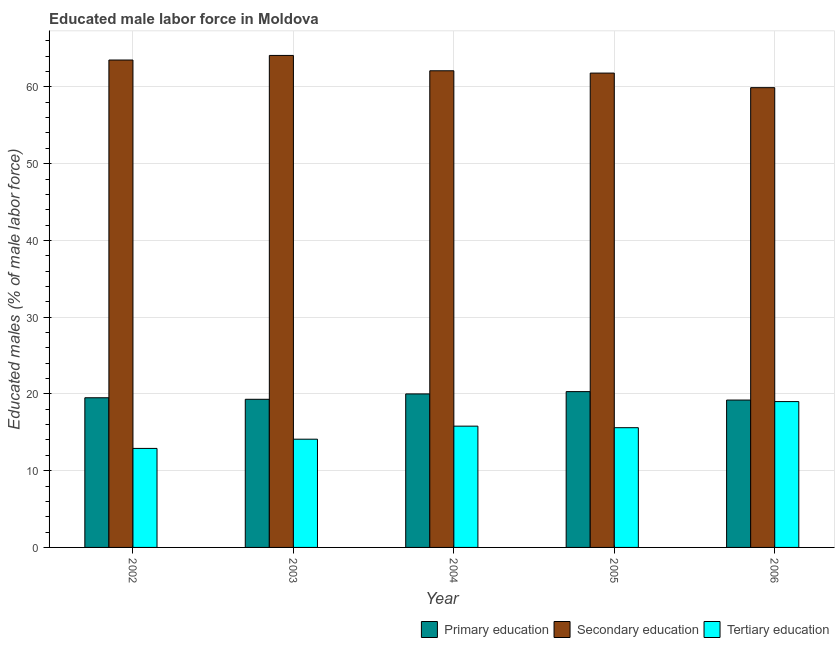How many different coloured bars are there?
Keep it short and to the point. 3. What is the percentage of male labor force who received secondary education in 2004?
Keep it short and to the point. 62.1. Across all years, what is the minimum percentage of male labor force who received tertiary education?
Ensure brevity in your answer.  12.9. In which year was the percentage of male labor force who received primary education maximum?
Your response must be concise. 2005. In which year was the percentage of male labor force who received secondary education minimum?
Make the answer very short. 2006. What is the total percentage of male labor force who received primary education in the graph?
Provide a succinct answer. 98.3. What is the difference between the percentage of male labor force who received secondary education in 2002 and that in 2006?
Your response must be concise. 3.6. What is the difference between the percentage of male labor force who received primary education in 2006 and the percentage of male labor force who received tertiary education in 2005?
Provide a short and direct response. -1.1. What is the average percentage of male labor force who received primary education per year?
Offer a terse response. 19.66. In how many years, is the percentage of male labor force who received tertiary education greater than 32 %?
Provide a succinct answer. 0. What is the ratio of the percentage of male labor force who received tertiary education in 2002 to that in 2005?
Ensure brevity in your answer.  0.83. Is the difference between the percentage of male labor force who received secondary education in 2002 and 2005 greater than the difference between the percentage of male labor force who received primary education in 2002 and 2005?
Your response must be concise. No. What is the difference between the highest and the second highest percentage of male labor force who received secondary education?
Keep it short and to the point. 0.6. What is the difference between the highest and the lowest percentage of male labor force who received primary education?
Your answer should be compact. 1.1. In how many years, is the percentage of male labor force who received tertiary education greater than the average percentage of male labor force who received tertiary education taken over all years?
Offer a terse response. 3. Is the sum of the percentage of male labor force who received primary education in 2004 and 2006 greater than the maximum percentage of male labor force who received tertiary education across all years?
Give a very brief answer. Yes. What does the 1st bar from the right in 2003 represents?
Your answer should be compact. Tertiary education. How many bars are there?
Offer a terse response. 15. Are the values on the major ticks of Y-axis written in scientific E-notation?
Offer a terse response. No. Does the graph contain any zero values?
Your response must be concise. No. Does the graph contain grids?
Your response must be concise. Yes. What is the title of the graph?
Your response must be concise. Educated male labor force in Moldova. What is the label or title of the X-axis?
Provide a short and direct response. Year. What is the label or title of the Y-axis?
Offer a very short reply. Educated males (% of male labor force). What is the Educated males (% of male labor force) of Primary education in 2002?
Give a very brief answer. 19.5. What is the Educated males (% of male labor force) in Secondary education in 2002?
Keep it short and to the point. 63.5. What is the Educated males (% of male labor force) of Tertiary education in 2002?
Ensure brevity in your answer.  12.9. What is the Educated males (% of male labor force) in Primary education in 2003?
Offer a terse response. 19.3. What is the Educated males (% of male labor force) in Secondary education in 2003?
Give a very brief answer. 64.1. What is the Educated males (% of male labor force) of Tertiary education in 2003?
Ensure brevity in your answer.  14.1. What is the Educated males (% of male labor force) of Secondary education in 2004?
Make the answer very short. 62.1. What is the Educated males (% of male labor force) of Tertiary education in 2004?
Provide a short and direct response. 15.8. What is the Educated males (% of male labor force) in Primary education in 2005?
Offer a very short reply. 20.3. What is the Educated males (% of male labor force) in Secondary education in 2005?
Offer a very short reply. 61.8. What is the Educated males (% of male labor force) in Tertiary education in 2005?
Provide a short and direct response. 15.6. What is the Educated males (% of male labor force) in Primary education in 2006?
Make the answer very short. 19.2. What is the Educated males (% of male labor force) of Secondary education in 2006?
Make the answer very short. 59.9. Across all years, what is the maximum Educated males (% of male labor force) of Primary education?
Your response must be concise. 20.3. Across all years, what is the maximum Educated males (% of male labor force) of Secondary education?
Ensure brevity in your answer.  64.1. Across all years, what is the maximum Educated males (% of male labor force) of Tertiary education?
Your response must be concise. 19. Across all years, what is the minimum Educated males (% of male labor force) of Primary education?
Give a very brief answer. 19.2. Across all years, what is the minimum Educated males (% of male labor force) in Secondary education?
Ensure brevity in your answer.  59.9. Across all years, what is the minimum Educated males (% of male labor force) of Tertiary education?
Your answer should be compact. 12.9. What is the total Educated males (% of male labor force) of Primary education in the graph?
Ensure brevity in your answer.  98.3. What is the total Educated males (% of male labor force) of Secondary education in the graph?
Ensure brevity in your answer.  311.4. What is the total Educated males (% of male labor force) in Tertiary education in the graph?
Provide a succinct answer. 77.4. What is the difference between the Educated males (% of male labor force) of Primary education in 2002 and that in 2003?
Offer a terse response. 0.2. What is the difference between the Educated males (% of male labor force) in Secondary education in 2002 and that in 2003?
Give a very brief answer. -0.6. What is the difference between the Educated males (% of male labor force) in Primary education in 2002 and that in 2004?
Offer a very short reply. -0.5. What is the difference between the Educated males (% of male labor force) in Tertiary education in 2002 and that in 2005?
Ensure brevity in your answer.  -2.7. What is the difference between the Educated males (% of male labor force) in Primary education in 2002 and that in 2006?
Offer a terse response. 0.3. What is the difference between the Educated males (% of male labor force) in Primary education in 2003 and that in 2004?
Provide a succinct answer. -0.7. What is the difference between the Educated males (% of male labor force) in Secondary education in 2003 and that in 2004?
Your answer should be very brief. 2. What is the difference between the Educated males (% of male labor force) in Primary education in 2003 and that in 2005?
Provide a short and direct response. -1. What is the difference between the Educated males (% of male labor force) in Primary education in 2003 and that in 2006?
Your answer should be compact. 0.1. What is the difference between the Educated males (% of male labor force) in Secondary education in 2003 and that in 2006?
Keep it short and to the point. 4.2. What is the difference between the Educated males (% of male labor force) of Tertiary education in 2004 and that in 2005?
Your answer should be very brief. 0.2. What is the difference between the Educated males (% of male labor force) in Secondary education in 2004 and that in 2006?
Your response must be concise. 2.2. What is the difference between the Educated males (% of male labor force) in Tertiary education in 2004 and that in 2006?
Provide a short and direct response. -3.2. What is the difference between the Educated males (% of male labor force) of Tertiary education in 2005 and that in 2006?
Give a very brief answer. -3.4. What is the difference between the Educated males (% of male labor force) of Primary education in 2002 and the Educated males (% of male labor force) of Secondary education in 2003?
Make the answer very short. -44.6. What is the difference between the Educated males (% of male labor force) in Secondary education in 2002 and the Educated males (% of male labor force) in Tertiary education in 2003?
Offer a very short reply. 49.4. What is the difference between the Educated males (% of male labor force) in Primary education in 2002 and the Educated males (% of male labor force) in Secondary education in 2004?
Provide a short and direct response. -42.6. What is the difference between the Educated males (% of male labor force) in Primary education in 2002 and the Educated males (% of male labor force) in Tertiary education in 2004?
Keep it short and to the point. 3.7. What is the difference between the Educated males (% of male labor force) of Secondary education in 2002 and the Educated males (% of male labor force) of Tertiary education in 2004?
Keep it short and to the point. 47.7. What is the difference between the Educated males (% of male labor force) in Primary education in 2002 and the Educated males (% of male labor force) in Secondary education in 2005?
Ensure brevity in your answer.  -42.3. What is the difference between the Educated males (% of male labor force) in Secondary education in 2002 and the Educated males (% of male labor force) in Tertiary education in 2005?
Provide a short and direct response. 47.9. What is the difference between the Educated males (% of male labor force) in Primary education in 2002 and the Educated males (% of male labor force) in Secondary education in 2006?
Your answer should be compact. -40.4. What is the difference between the Educated males (% of male labor force) in Secondary education in 2002 and the Educated males (% of male labor force) in Tertiary education in 2006?
Offer a very short reply. 44.5. What is the difference between the Educated males (% of male labor force) of Primary education in 2003 and the Educated males (% of male labor force) of Secondary education in 2004?
Make the answer very short. -42.8. What is the difference between the Educated males (% of male labor force) in Secondary education in 2003 and the Educated males (% of male labor force) in Tertiary education in 2004?
Offer a very short reply. 48.3. What is the difference between the Educated males (% of male labor force) in Primary education in 2003 and the Educated males (% of male labor force) in Secondary education in 2005?
Make the answer very short. -42.5. What is the difference between the Educated males (% of male labor force) of Secondary education in 2003 and the Educated males (% of male labor force) of Tertiary education in 2005?
Your answer should be very brief. 48.5. What is the difference between the Educated males (% of male labor force) of Primary education in 2003 and the Educated males (% of male labor force) of Secondary education in 2006?
Your answer should be compact. -40.6. What is the difference between the Educated males (% of male labor force) of Secondary education in 2003 and the Educated males (% of male labor force) of Tertiary education in 2006?
Your response must be concise. 45.1. What is the difference between the Educated males (% of male labor force) in Primary education in 2004 and the Educated males (% of male labor force) in Secondary education in 2005?
Offer a very short reply. -41.8. What is the difference between the Educated males (% of male labor force) of Primary education in 2004 and the Educated males (% of male labor force) of Tertiary education in 2005?
Offer a terse response. 4.4. What is the difference between the Educated males (% of male labor force) of Secondary education in 2004 and the Educated males (% of male labor force) of Tertiary education in 2005?
Ensure brevity in your answer.  46.5. What is the difference between the Educated males (% of male labor force) in Primary education in 2004 and the Educated males (% of male labor force) in Secondary education in 2006?
Provide a short and direct response. -39.9. What is the difference between the Educated males (% of male labor force) in Secondary education in 2004 and the Educated males (% of male labor force) in Tertiary education in 2006?
Offer a very short reply. 43.1. What is the difference between the Educated males (% of male labor force) of Primary education in 2005 and the Educated males (% of male labor force) of Secondary education in 2006?
Ensure brevity in your answer.  -39.6. What is the difference between the Educated males (% of male labor force) of Secondary education in 2005 and the Educated males (% of male labor force) of Tertiary education in 2006?
Provide a short and direct response. 42.8. What is the average Educated males (% of male labor force) of Primary education per year?
Provide a short and direct response. 19.66. What is the average Educated males (% of male labor force) of Secondary education per year?
Provide a succinct answer. 62.28. What is the average Educated males (% of male labor force) of Tertiary education per year?
Your answer should be compact. 15.48. In the year 2002, what is the difference between the Educated males (% of male labor force) in Primary education and Educated males (% of male labor force) in Secondary education?
Provide a succinct answer. -44. In the year 2002, what is the difference between the Educated males (% of male labor force) in Primary education and Educated males (% of male labor force) in Tertiary education?
Keep it short and to the point. 6.6. In the year 2002, what is the difference between the Educated males (% of male labor force) of Secondary education and Educated males (% of male labor force) of Tertiary education?
Your answer should be compact. 50.6. In the year 2003, what is the difference between the Educated males (% of male labor force) in Primary education and Educated males (% of male labor force) in Secondary education?
Give a very brief answer. -44.8. In the year 2003, what is the difference between the Educated males (% of male labor force) of Primary education and Educated males (% of male labor force) of Tertiary education?
Keep it short and to the point. 5.2. In the year 2003, what is the difference between the Educated males (% of male labor force) in Secondary education and Educated males (% of male labor force) in Tertiary education?
Provide a succinct answer. 50. In the year 2004, what is the difference between the Educated males (% of male labor force) of Primary education and Educated males (% of male labor force) of Secondary education?
Your response must be concise. -42.1. In the year 2004, what is the difference between the Educated males (% of male labor force) in Primary education and Educated males (% of male labor force) in Tertiary education?
Offer a very short reply. 4.2. In the year 2004, what is the difference between the Educated males (% of male labor force) of Secondary education and Educated males (% of male labor force) of Tertiary education?
Your answer should be compact. 46.3. In the year 2005, what is the difference between the Educated males (% of male labor force) in Primary education and Educated males (% of male labor force) in Secondary education?
Provide a short and direct response. -41.5. In the year 2005, what is the difference between the Educated males (% of male labor force) in Secondary education and Educated males (% of male labor force) in Tertiary education?
Provide a succinct answer. 46.2. In the year 2006, what is the difference between the Educated males (% of male labor force) in Primary education and Educated males (% of male labor force) in Secondary education?
Provide a short and direct response. -40.7. In the year 2006, what is the difference between the Educated males (% of male labor force) in Primary education and Educated males (% of male labor force) in Tertiary education?
Provide a succinct answer. 0.2. In the year 2006, what is the difference between the Educated males (% of male labor force) of Secondary education and Educated males (% of male labor force) of Tertiary education?
Give a very brief answer. 40.9. What is the ratio of the Educated males (% of male labor force) of Primary education in 2002 to that in 2003?
Offer a terse response. 1.01. What is the ratio of the Educated males (% of male labor force) in Secondary education in 2002 to that in 2003?
Keep it short and to the point. 0.99. What is the ratio of the Educated males (% of male labor force) in Tertiary education in 2002 to that in 2003?
Make the answer very short. 0.91. What is the ratio of the Educated males (% of male labor force) in Secondary education in 2002 to that in 2004?
Provide a short and direct response. 1.02. What is the ratio of the Educated males (% of male labor force) of Tertiary education in 2002 to that in 2004?
Offer a very short reply. 0.82. What is the ratio of the Educated males (% of male labor force) in Primary education in 2002 to that in 2005?
Your answer should be very brief. 0.96. What is the ratio of the Educated males (% of male labor force) of Secondary education in 2002 to that in 2005?
Ensure brevity in your answer.  1.03. What is the ratio of the Educated males (% of male labor force) of Tertiary education in 2002 to that in 2005?
Your answer should be compact. 0.83. What is the ratio of the Educated males (% of male labor force) in Primary education in 2002 to that in 2006?
Provide a succinct answer. 1.02. What is the ratio of the Educated males (% of male labor force) of Secondary education in 2002 to that in 2006?
Your answer should be compact. 1.06. What is the ratio of the Educated males (% of male labor force) in Tertiary education in 2002 to that in 2006?
Offer a very short reply. 0.68. What is the ratio of the Educated males (% of male labor force) of Secondary education in 2003 to that in 2004?
Give a very brief answer. 1.03. What is the ratio of the Educated males (% of male labor force) of Tertiary education in 2003 to that in 2004?
Provide a short and direct response. 0.89. What is the ratio of the Educated males (% of male labor force) of Primary education in 2003 to that in 2005?
Ensure brevity in your answer.  0.95. What is the ratio of the Educated males (% of male labor force) of Secondary education in 2003 to that in 2005?
Provide a succinct answer. 1.04. What is the ratio of the Educated males (% of male labor force) of Tertiary education in 2003 to that in 2005?
Give a very brief answer. 0.9. What is the ratio of the Educated males (% of male labor force) of Primary education in 2003 to that in 2006?
Provide a succinct answer. 1.01. What is the ratio of the Educated males (% of male labor force) of Secondary education in 2003 to that in 2006?
Provide a short and direct response. 1.07. What is the ratio of the Educated males (% of male labor force) in Tertiary education in 2003 to that in 2006?
Your response must be concise. 0.74. What is the ratio of the Educated males (% of male labor force) of Primary education in 2004 to that in 2005?
Keep it short and to the point. 0.99. What is the ratio of the Educated males (% of male labor force) in Tertiary education in 2004 to that in 2005?
Give a very brief answer. 1.01. What is the ratio of the Educated males (% of male labor force) in Primary education in 2004 to that in 2006?
Offer a terse response. 1.04. What is the ratio of the Educated males (% of male labor force) in Secondary education in 2004 to that in 2006?
Ensure brevity in your answer.  1.04. What is the ratio of the Educated males (% of male labor force) of Tertiary education in 2004 to that in 2006?
Your answer should be very brief. 0.83. What is the ratio of the Educated males (% of male labor force) of Primary education in 2005 to that in 2006?
Make the answer very short. 1.06. What is the ratio of the Educated males (% of male labor force) in Secondary education in 2005 to that in 2006?
Offer a terse response. 1.03. What is the ratio of the Educated males (% of male labor force) of Tertiary education in 2005 to that in 2006?
Make the answer very short. 0.82. What is the difference between the highest and the second highest Educated males (% of male labor force) in Primary education?
Provide a short and direct response. 0.3. What is the difference between the highest and the second highest Educated males (% of male labor force) of Tertiary education?
Provide a succinct answer. 3.2. What is the difference between the highest and the lowest Educated males (% of male labor force) of Secondary education?
Give a very brief answer. 4.2. 